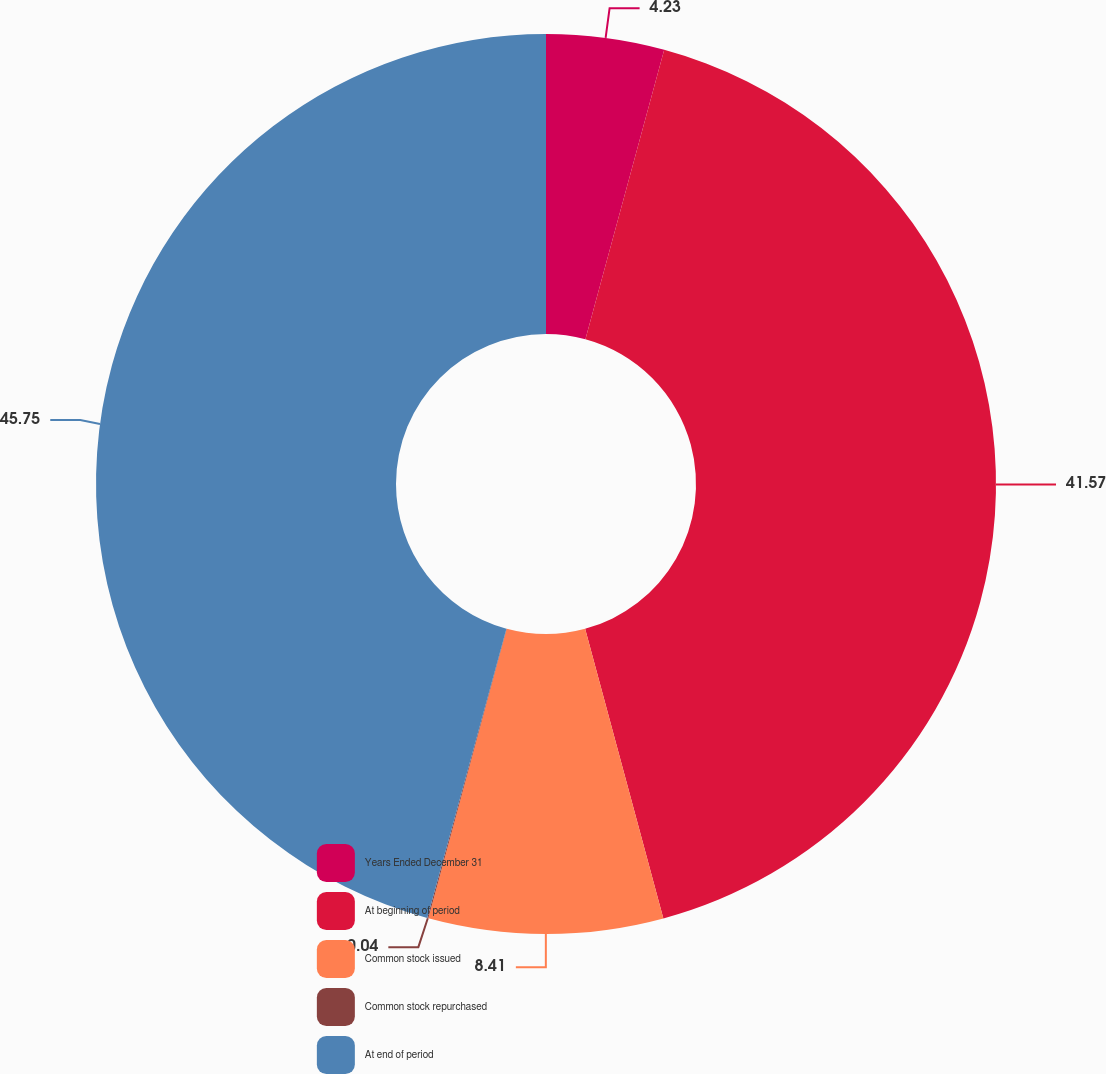<chart> <loc_0><loc_0><loc_500><loc_500><pie_chart><fcel>Years Ended December 31<fcel>At beginning of period<fcel>Common stock issued<fcel>Common stock repurchased<fcel>At end of period<nl><fcel>4.23%<fcel>41.57%<fcel>8.41%<fcel>0.04%<fcel>45.75%<nl></chart> 